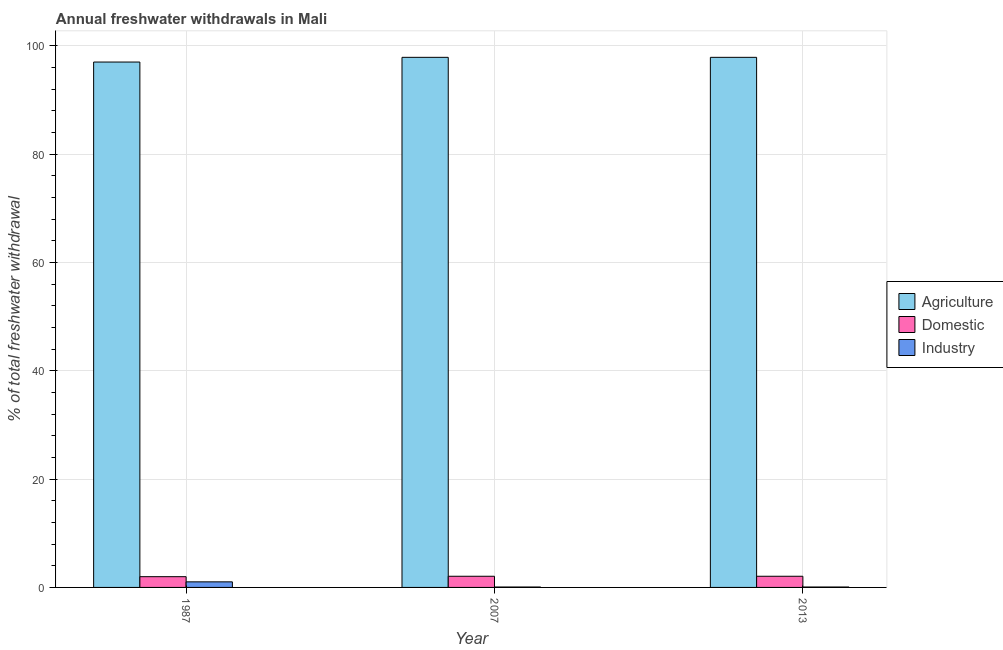How many different coloured bars are there?
Make the answer very short. 3. What is the percentage of freshwater withdrawal for domestic purposes in 2007?
Offer a very short reply. 2.06. Across all years, what is the maximum percentage of freshwater withdrawal for agriculture?
Give a very brief answer. 97.86. Across all years, what is the minimum percentage of freshwater withdrawal for agriculture?
Keep it short and to the point. 96.99. What is the total percentage of freshwater withdrawal for industry in the graph?
Your response must be concise. 1.18. What is the difference between the percentage of freshwater withdrawal for domestic purposes in 2007 and that in 2013?
Your response must be concise. 0. What is the difference between the percentage of freshwater withdrawal for agriculture in 2007 and the percentage of freshwater withdrawal for industry in 1987?
Ensure brevity in your answer.  0.87. What is the average percentage of freshwater withdrawal for industry per year?
Keep it short and to the point. 0.39. In how many years, is the percentage of freshwater withdrawal for industry greater than 8 %?
Make the answer very short. 0. What is the ratio of the percentage of freshwater withdrawal for industry in 2007 to that in 2013?
Ensure brevity in your answer.  1. What is the difference between the highest and the second highest percentage of freshwater withdrawal for domestic purposes?
Keep it short and to the point. 0. What is the difference between the highest and the lowest percentage of freshwater withdrawal for agriculture?
Make the answer very short. 0.87. What does the 1st bar from the left in 2013 represents?
Provide a short and direct response. Agriculture. What does the 2nd bar from the right in 2007 represents?
Keep it short and to the point. Domestic. How many bars are there?
Your response must be concise. 9. Are all the bars in the graph horizontal?
Make the answer very short. No. How many years are there in the graph?
Your answer should be compact. 3. Does the graph contain grids?
Make the answer very short. Yes. What is the title of the graph?
Your answer should be very brief. Annual freshwater withdrawals in Mali. Does "Communicable diseases" appear as one of the legend labels in the graph?
Your answer should be very brief. No. What is the label or title of the X-axis?
Provide a succinct answer. Year. What is the label or title of the Y-axis?
Provide a succinct answer. % of total freshwater withdrawal. What is the % of total freshwater withdrawal in Agriculture in 1987?
Ensure brevity in your answer.  96.99. What is the % of total freshwater withdrawal of Domestic in 1987?
Give a very brief answer. 1.99. What is the % of total freshwater withdrawal of Agriculture in 2007?
Make the answer very short. 97.86. What is the % of total freshwater withdrawal of Domestic in 2007?
Your answer should be compact. 2.06. What is the % of total freshwater withdrawal of Industry in 2007?
Keep it short and to the point. 0.08. What is the % of total freshwater withdrawal of Agriculture in 2013?
Your response must be concise. 97.86. What is the % of total freshwater withdrawal in Domestic in 2013?
Your answer should be very brief. 2.06. What is the % of total freshwater withdrawal of Industry in 2013?
Ensure brevity in your answer.  0.08. Across all years, what is the maximum % of total freshwater withdrawal in Agriculture?
Keep it short and to the point. 97.86. Across all years, what is the maximum % of total freshwater withdrawal in Domestic?
Provide a succinct answer. 2.06. Across all years, what is the maximum % of total freshwater withdrawal in Industry?
Offer a terse response. 1.03. Across all years, what is the minimum % of total freshwater withdrawal of Agriculture?
Ensure brevity in your answer.  96.99. Across all years, what is the minimum % of total freshwater withdrawal of Domestic?
Offer a terse response. 1.99. Across all years, what is the minimum % of total freshwater withdrawal in Industry?
Make the answer very short. 0.08. What is the total % of total freshwater withdrawal of Agriculture in the graph?
Offer a very short reply. 292.71. What is the total % of total freshwater withdrawal of Domestic in the graph?
Your answer should be very brief. 6.11. What is the total % of total freshwater withdrawal in Industry in the graph?
Your answer should be compact. 1.18. What is the difference between the % of total freshwater withdrawal of Agriculture in 1987 and that in 2007?
Provide a succinct answer. -0.87. What is the difference between the % of total freshwater withdrawal of Domestic in 1987 and that in 2007?
Your answer should be compact. -0.08. What is the difference between the % of total freshwater withdrawal of Industry in 1987 and that in 2007?
Offer a terse response. 0.95. What is the difference between the % of total freshwater withdrawal of Agriculture in 1987 and that in 2013?
Keep it short and to the point. -0.87. What is the difference between the % of total freshwater withdrawal in Domestic in 1987 and that in 2013?
Your answer should be very brief. -0.08. What is the difference between the % of total freshwater withdrawal in Industry in 1987 and that in 2013?
Make the answer very short. 0.95. What is the difference between the % of total freshwater withdrawal of Domestic in 2007 and that in 2013?
Your answer should be compact. 0. What is the difference between the % of total freshwater withdrawal in Industry in 2007 and that in 2013?
Provide a succinct answer. 0. What is the difference between the % of total freshwater withdrawal of Agriculture in 1987 and the % of total freshwater withdrawal of Domestic in 2007?
Your answer should be very brief. 94.93. What is the difference between the % of total freshwater withdrawal of Agriculture in 1987 and the % of total freshwater withdrawal of Industry in 2007?
Ensure brevity in your answer.  96.91. What is the difference between the % of total freshwater withdrawal of Domestic in 1987 and the % of total freshwater withdrawal of Industry in 2007?
Make the answer very short. 1.91. What is the difference between the % of total freshwater withdrawal in Agriculture in 1987 and the % of total freshwater withdrawal in Domestic in 2013?
Offer a terse response. 94.93. What is the difference between the % of total freshwater withdrawal in Agriculture in 1987 and the % of total freshwater withdrawal in Industry in 2013?
Offer a very short reply. 96.91. What is the difference between the % of total freshwater withdrawal in Domestic in 1987 and the % of total freshwater withdrawal in Industry in 2013?
Offer a terse response. 1.91. What is the difference between the % of total freshwater withdrawal of Agriculture in 2007 and the % of total freshwater withdrawal of Domestic in 2013?
Your answer should be compact. 95.8. What is the difference between the % of total freshwater withdrawal in Agriculture in 2007 and the % of total freshwater withdrawal in Industry in 2013?
Offer a very short reply. 97.78. What is the difference between the % of total freshwater withdrawal of Domestic in 2007 and the % of total freshwater withdrawal of Industry in 2013?
Keep it short and to the point. 1.99. What is the average % of total freshwater withdrawal of Agriculture per year?
Provide a succinct answer. 97.57. What is the average % of total freshwater withdrawal in Domestic per year?
Offer a very short reply. 2.04. What is the average % of total freshwater withdrawal of Industry per year?
Keep it short and to the point. 0.39. In the year 1987, what is the difference between the % of total freshwater withdrawal of Agriculture and % of total freshwater withdrawal of Domestic?
Make the answer very short. 95. In the year 1987, what is the difference between the % of total freshwater withdrawal of Agriculture and % of total freshwater withdrawal of Industry?
Provide a short and direct response. 95.96. In the year 1987, what is the difference between the % of total freshwater withdrawal of Domestic and % of total freshwater withdrawal of Industry?
Make the answer very short. 0.96. In the year 2007, what is the difference between the % of total freshwater withdrawal of Agriculture and % of total freshwater withdrawal of Domestic?
Your response must be concise. 95.8. In the year 2007, what is the difference between the % of total freshwater withdrawal in Agriculture and % of total freshwater withdrawal in Industry?
Make the answer very short. 97.78. In the year 2007, what is the difference between the % of total freshwater withdrawal in Domestic and % of total freshwater withdrawal in Industry?
Your answer should be very brief. 1.99. In the year 2013, what is the difference between the % of total freshwater withdrawal of Agriculture and % of total freshwater withdrawal of Domestic?
Your answer should be compact. 95.8. In the year 2013, what is the difference between the % of total freshwater withdrawal of Agriculture and % of total freshwater withdrawal of Industry?
Offer a terse response. 97.78. In the year 2013, what is the difference between the % of total freshwater withdrawal of Domestic and % of total freshwater withdrawal of Industry?
Offer a very short reply. 1.99. What is the ratio of the % of total freshwater withdrawal in Domestic in 1987 to that in 2007?
Your answer should be compact. 0.96. What is the ratio of the % of total freshwater withdrawal in Industry in 1987 to that in 2007?
Make the answer very short. 13.35. What is the ratio of the % of total freshwater withdrawal of Agriculture in 1987 to that in 2013?
Your response must be concise. 0.99. What is the ratio of the % of total freshwater withdrawal of Domestic in 1987 to that in 2013?
Make the answer very short. 0.96. What is the ratio of the % of total freshwater withdrawal in Industry in 1987 to that in 2013?
Offer a terse response. 13.35. What is the ratio of the % of total freshwater withdrawal in Agriculture in 2007 to that in 2013?
Your answer should be compact. 1. What is the difference between the highest and the second highest % of total freshwater withdrawal of Domestic?
Make the answer very short. 0. What is the difference between the highest and the second highest % of total freshwater withdrawal of Industry?
Make the answer very short. 0.95. What is the difference between the highest and the lowest % of total freshwater withdrawal in Agriculture?
Your answer should be very brief. 0.87. What is the difference between the highest and the lowest % of total freshwater withdrawal of Domestic?
Provide a short and direct response. 0.08. What is the difference between the highest and the lowest % of total freshwater withdrawal in Industry?
Keep it short and to the point. 0.95. 